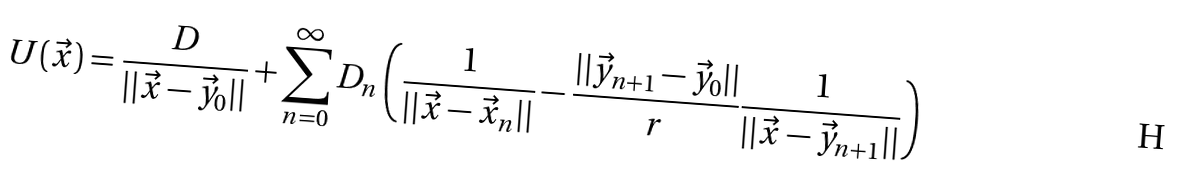<formula> <loc_0><loc_0><loc_500><loc_500>U ( \vec { x } ) = \frac { D } { | | \vec { x } - \vec { y } _ { 0 } | | } + \sum _ { n = 0 } ^ { \infty } D _ { n } \left ( \frac { 1 } { | | \vec { x } - \vec { x } _ { n } | | } - \frac { | | \vec { y } _ { n + 1 } - \vec { y } _ { 0 } | | } { r } \frac { 1 } { | | \vec { x } - \vec { y } _ { n + 1 } | | } \right )</formula> 